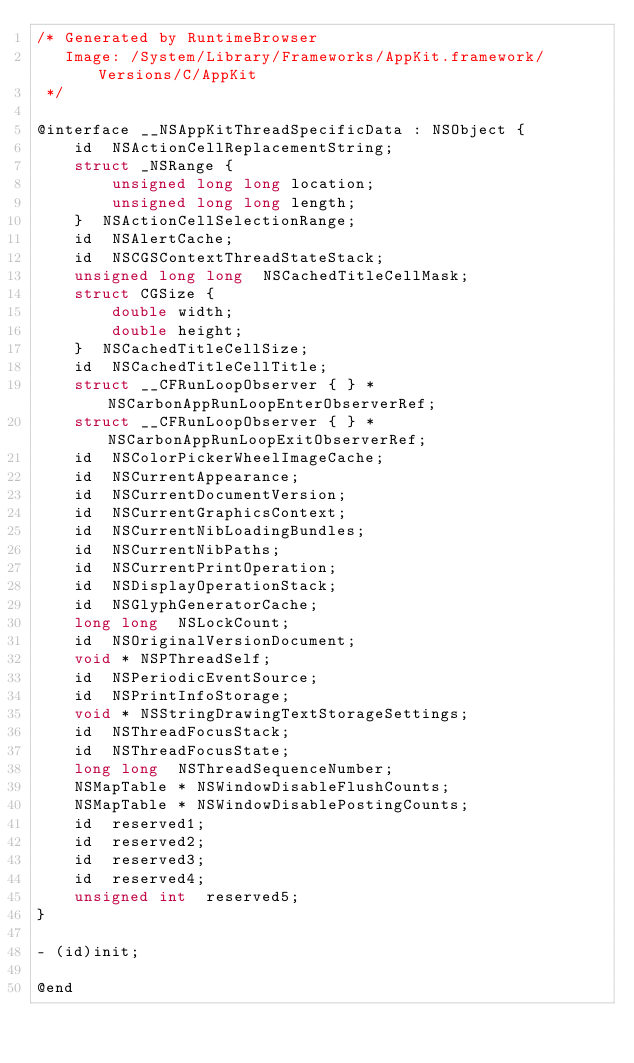Convert code to text. <code><loc_0><loc_0><loc_500><loc_500><_C_>/* Generated by RuntimeBrowser
   Image: /System/Library/Frameworks/AppKit.framework/Versions/C/AppKit
 */

@interface __NSAppKitThreadSpecificData : NSObject {
    id  NSActionCellReplacementString;
    struct _NSRange { 
        unsigned long long location; 
        unsigned long long length; 
    }  NSActionCellSelectionRange;
    id  NSAlertCache;
    id  NSCGSContextThreadStateStack;
    unsigned long long  NSCachedTitleCellMask;
    struct CGSize { 
        double width; 
        double height; 
    }  NSCachedTitleCellSize;
    id  NSCachedTitleCellTitle;
    struct __CFRunLoopObserver { } * NSCarbonAppRunLoopEnterObserverRef;
    struct __CFRunLoopObserver { } * NSCarbonAppRunLoopExitObserverRef;
    id  NSColorPickerWheelImageCache;
    id  NSCurrentAppearance;
    id  NSCurrentDocumentVersion;
    id  NSCurrentGraphicsContext;
    id  NSCurrentNibLoadingBundles;
    id  NSCurrentNibPaths;
    id  NSCurrentPrintOperation;
    id  NSDisplayOperationStack;
    id  NSGlyphGeneratorCache;
    long long  NSLockCount;
    id  NSOriginalVersionDocument;
    void * NSPThreadSelf;
    id  NSPeriodicEventSource;
    id  NSPrintInfoStorage;
    void * NSStringDrawingTextStorageSettings;
    id  NSThreadFocusStack;
    id  NSThreadFocusState;
    long long  NSThreadSequenceNumber;
    NSMapTable * NSWindowDisableFlushCounts;
    NSMapTable * NSWindowDisablePostingCounts;
    id  reserved1;
    id  reserved2;
    id  reserved3;
    id  reserved4;
    unsigned int  reserved5;
}

- (id)init;

@end
</code> 